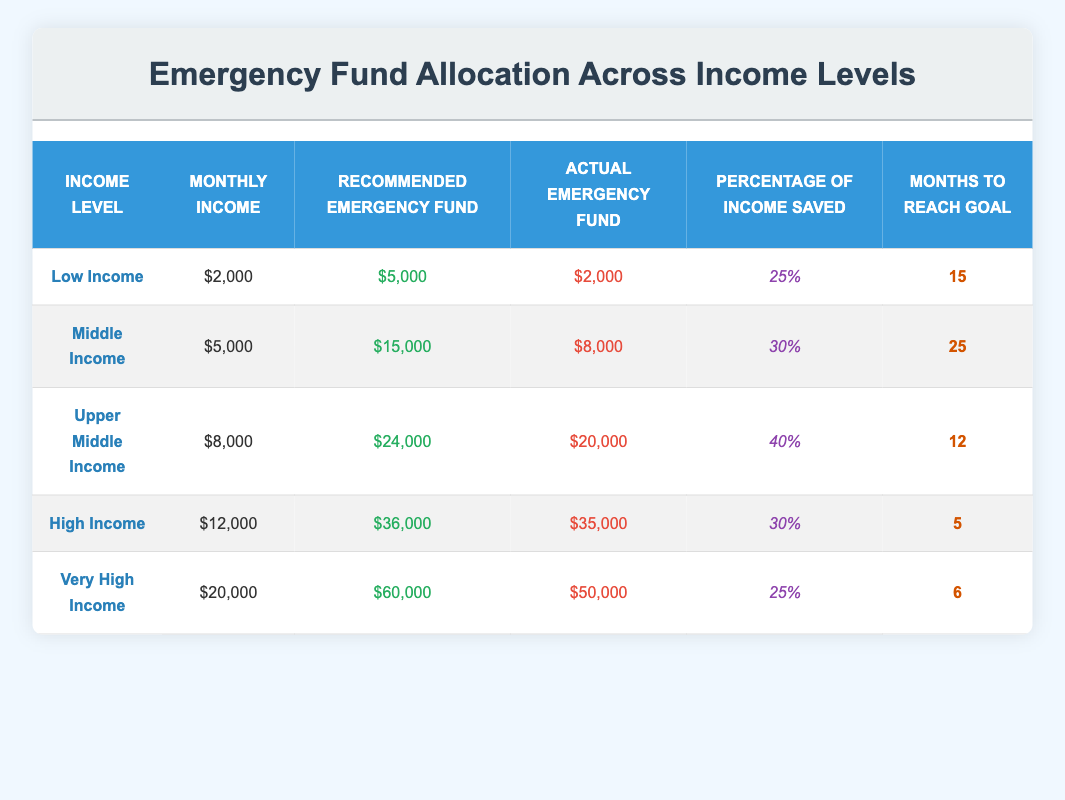What is the recommended emergency fund for high-income individuals? The table shows that the recommended emergency fund for high-income individuals is $36,000 as indicated in the "Recommended Emergency Fund" column under the "High Income" row.
Answer: $36,000 How much actual emergency fund do middle-income earners have? The "Actual Emergency Fund" for middle-income individuals can be found in the table under the "Middle Income" row, which states it is $8,000.
Answer: $8,000 Which income level has the shortest time to reach their emergency fund goal? To determine this, we compare the "Months to Reach Goal" for all income levels. The "High Income" level indicates just 5 months, which is the minimum compared to others.
Answer: High Income Is it true that upper middle-income individuals save a higher percentage of their income compared to middle-income individuals? In the table, upper middle-income individuals save 40% of their income, while middle-income individuals save 30%. Therefore, it is true that upper middle-income individuals save a higher percentage.
Answer: Yes What is the total recommended emergency fund for low and very high-income individuals combined? The recommended emergency fund for low income is $5,000 and for very high income is $60,000. Adding them together: $5,000 + $60,000 = $65,000.
Answer: $65,000 How many total months would it take for the upper middle-income group and the high-income group to reach their emergency fund goals? We will sum the "Months to Reach Goal" for upper middle income (12 months) and high income (5 months): 12 + 5 = 17 months.
Answer: 17 months What percentage of income saved do very high-income individuals have? The table states that very high-income individuals save 25% of their income, which is directly mentioned in the "Percentage of Income Saved" column for that group.
Answer: 25% Is the actual emergency fund of low-income individuals below or above their recommended emergency fund? The table indicates that the actual emergency fund for low-income individuals is $2,000, while their recommended emergency fund is $5,000. Since $2,000 is less than $5,000, the actual fund is below the recommendation.
Answer: Below Which income group has the highest monthly income? The table lists the monthly incomes for each group, and the highest is $20,000 for the very high-income group.
Answer: Very High Income 